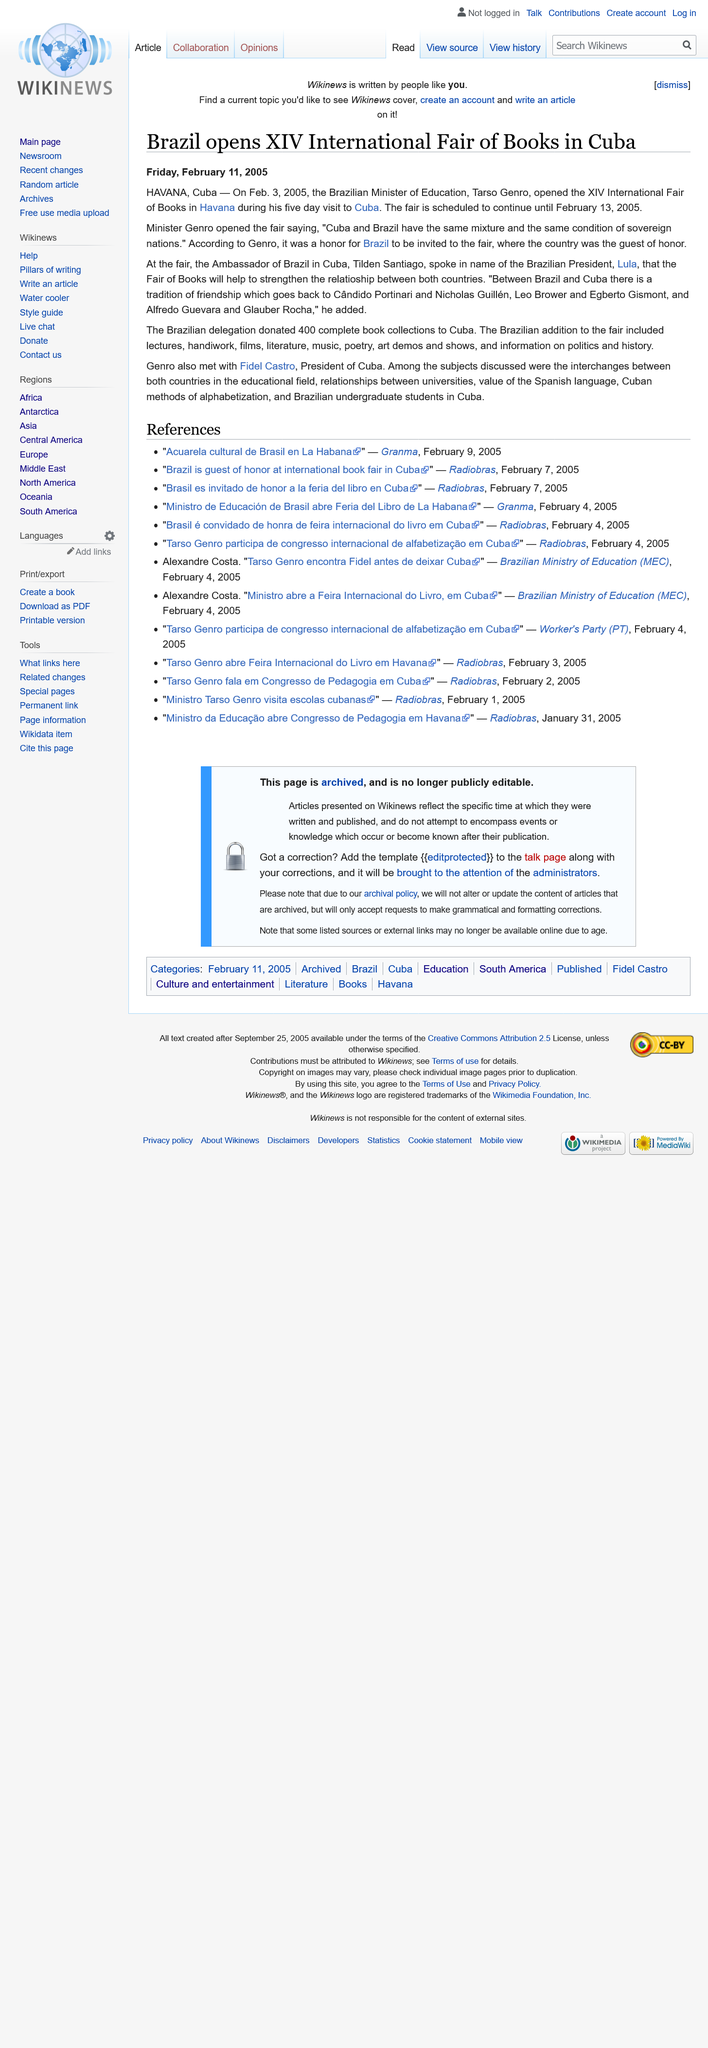Outline some significant characteristics in this image. On February 3rd, 2005, the XIV International Fair of Books in Cuba was opened. The fair took place in Havana, as stated in the text. The Brazilian Minister of Education, Tarso Genro, stated that Cuba and Brazil share the same mixture and condition as sovereign nations. He also stated that it was an honor for Brazil to be invited to the Fair. 